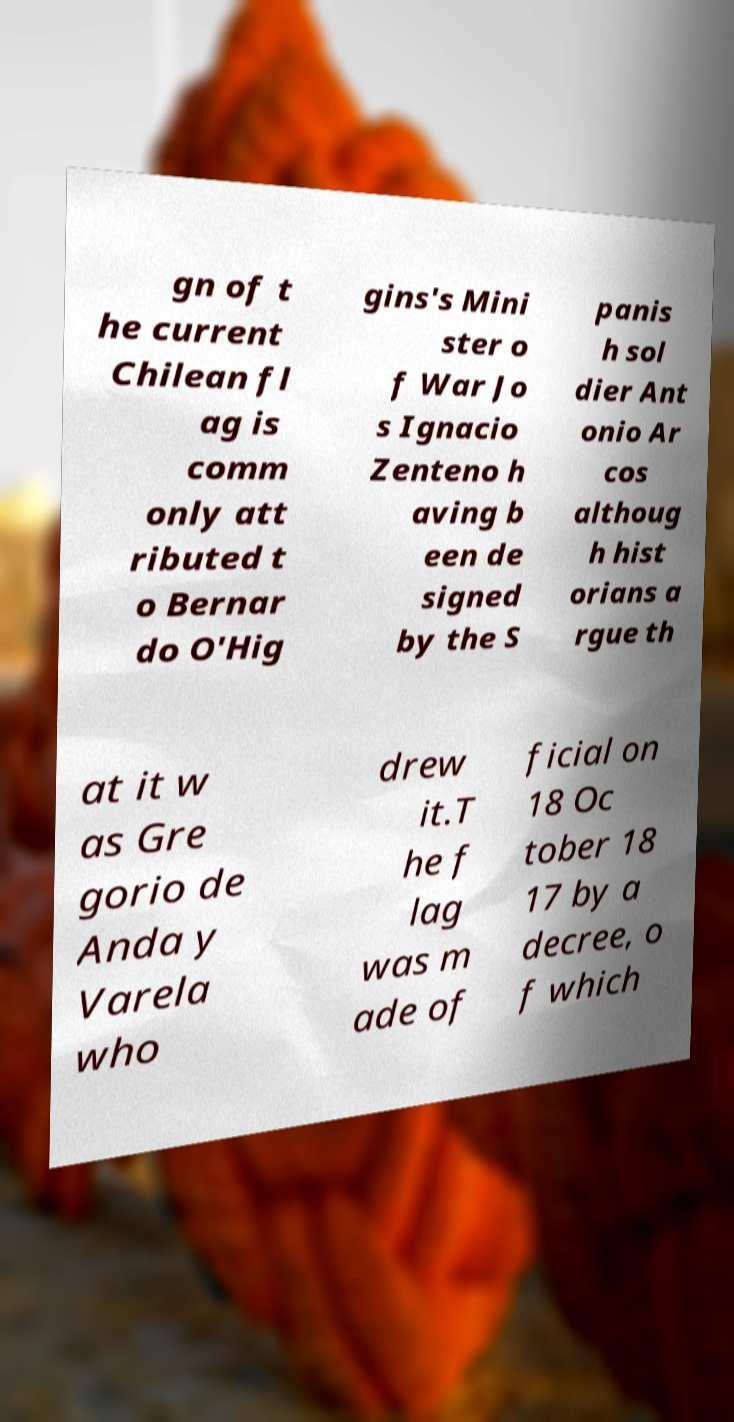Can you accurately transcribe the text from the provided image for me? gn of t he current Chilean fl ag is comm only att ributed t o Bernar do O'Hig gins's Mini ster o f War Jo s Ignacio Zenteno h aving b een de signed by the S panis h sol dier Ant onio Ar cos althoug h hist orians a rgue th at it w as Gre gorio de Anda y Varela who drew it.T he f lag was m ade of ficial on 18 Oc tober 18 17 by a decree, o f which 